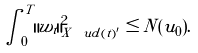Convert formula to latex. <formula><loc_0><loc_0><loc_500><loc_500>\int _ { 0 } ^ { T } \| w _ { t } \| ^ { 2 } _ { X ^ { \ } u d ( t ) ^ { \prime } } \leq N ( u _ { 0 } ) .</formula> 